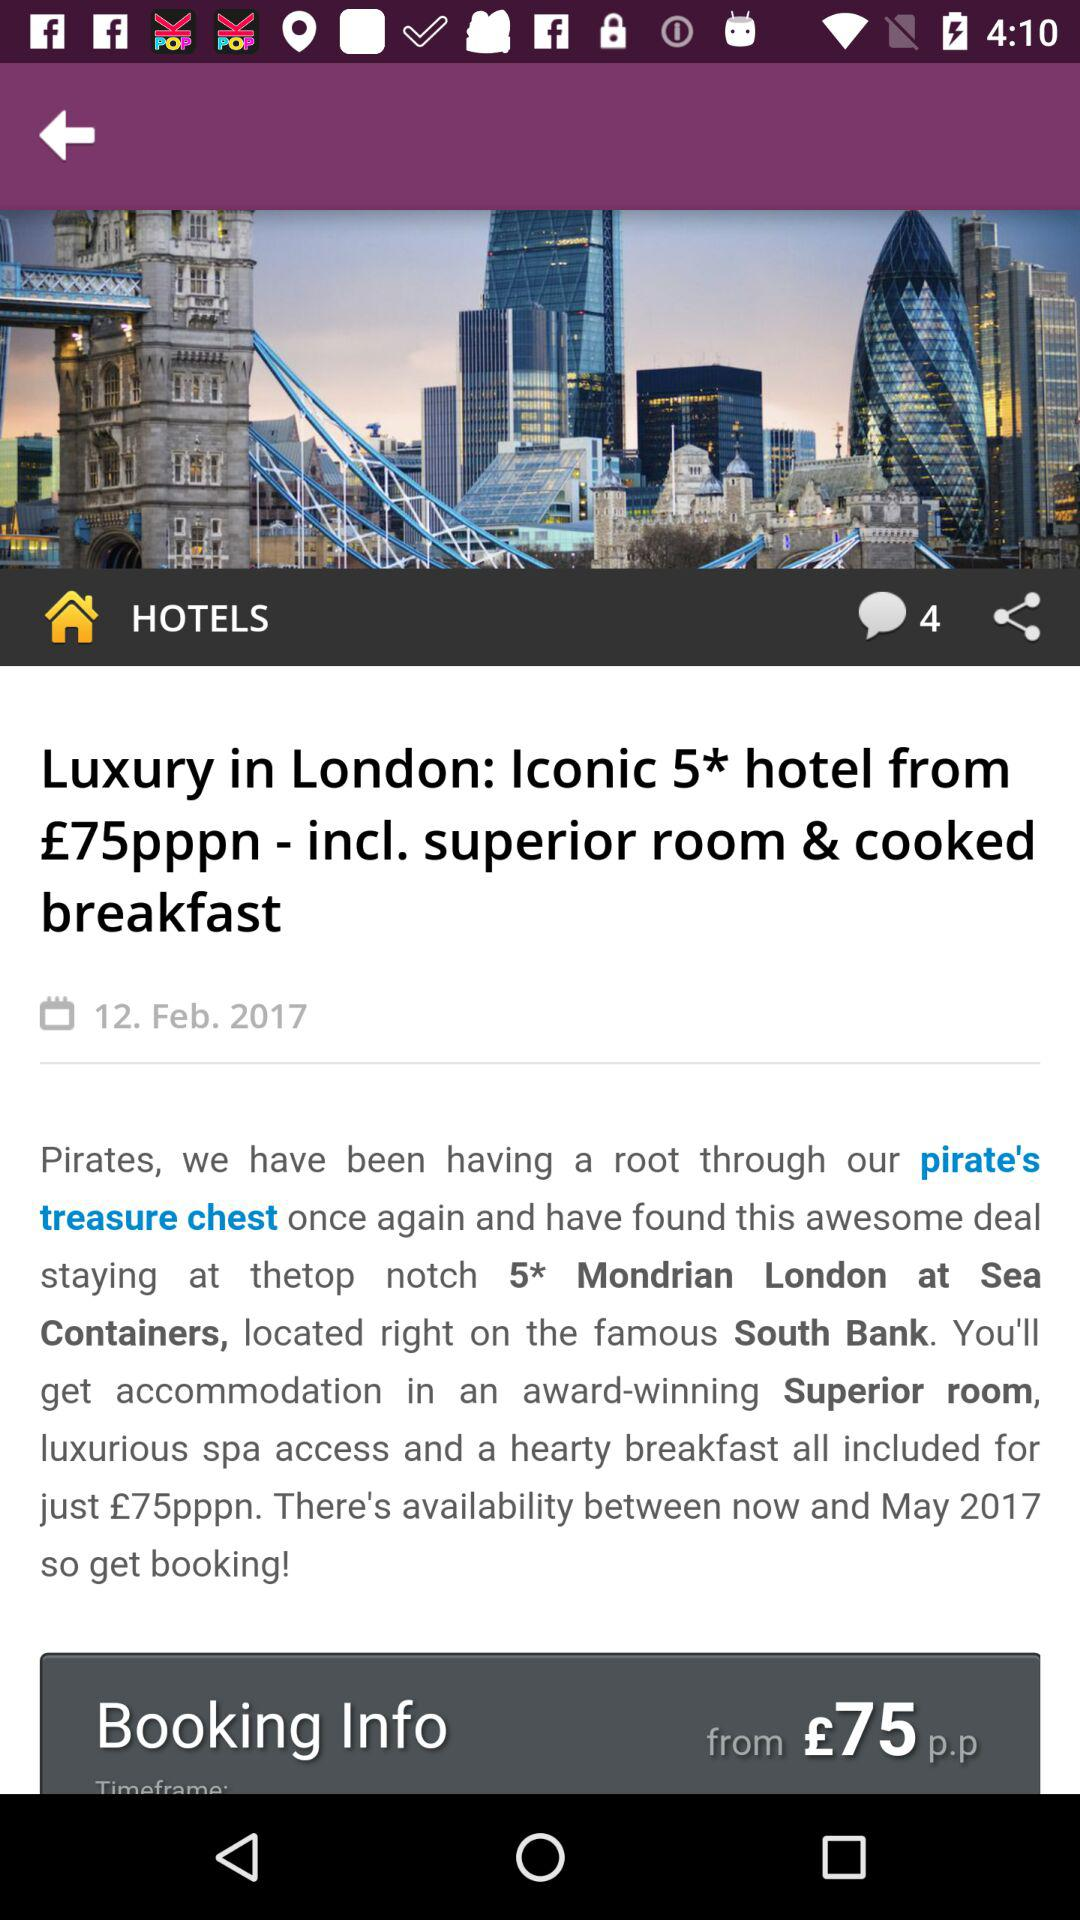What is the date? The date is February 12, 2017. 